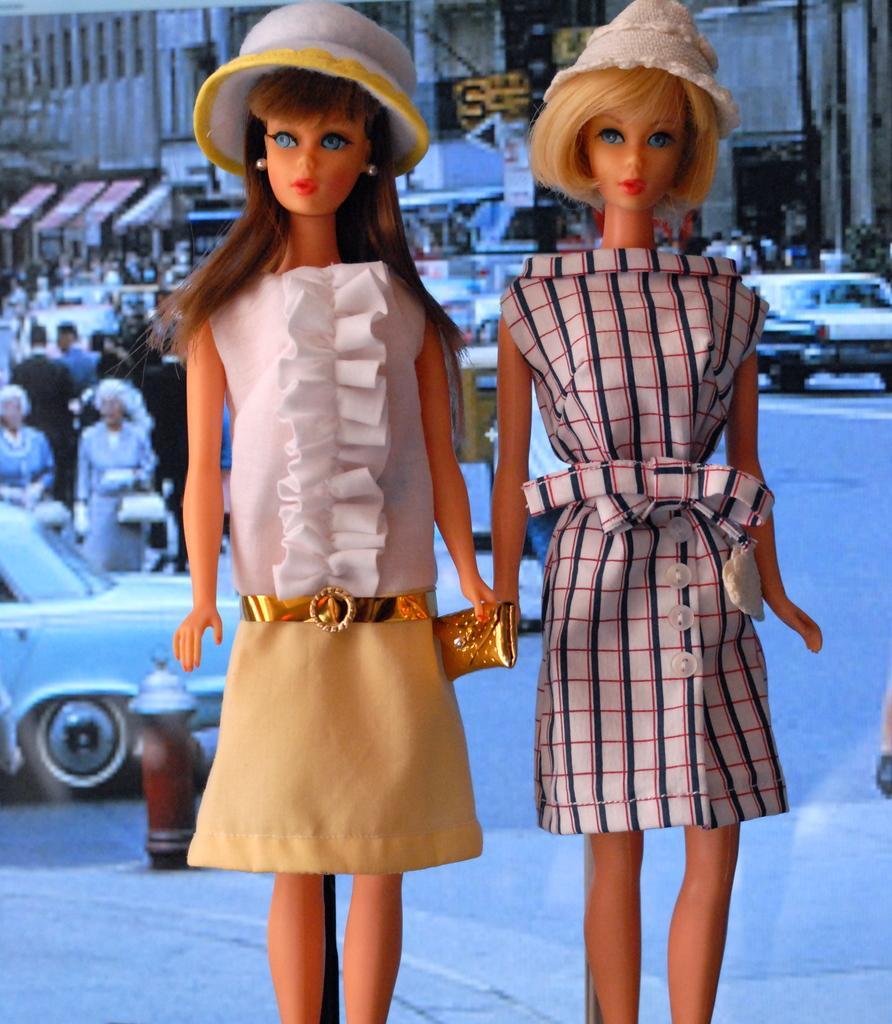How would you summarize this image in a sentence or two? There are toys in the foreground area of the image, there are people, vehicles, trees, posters, stalls and a building in the background. 